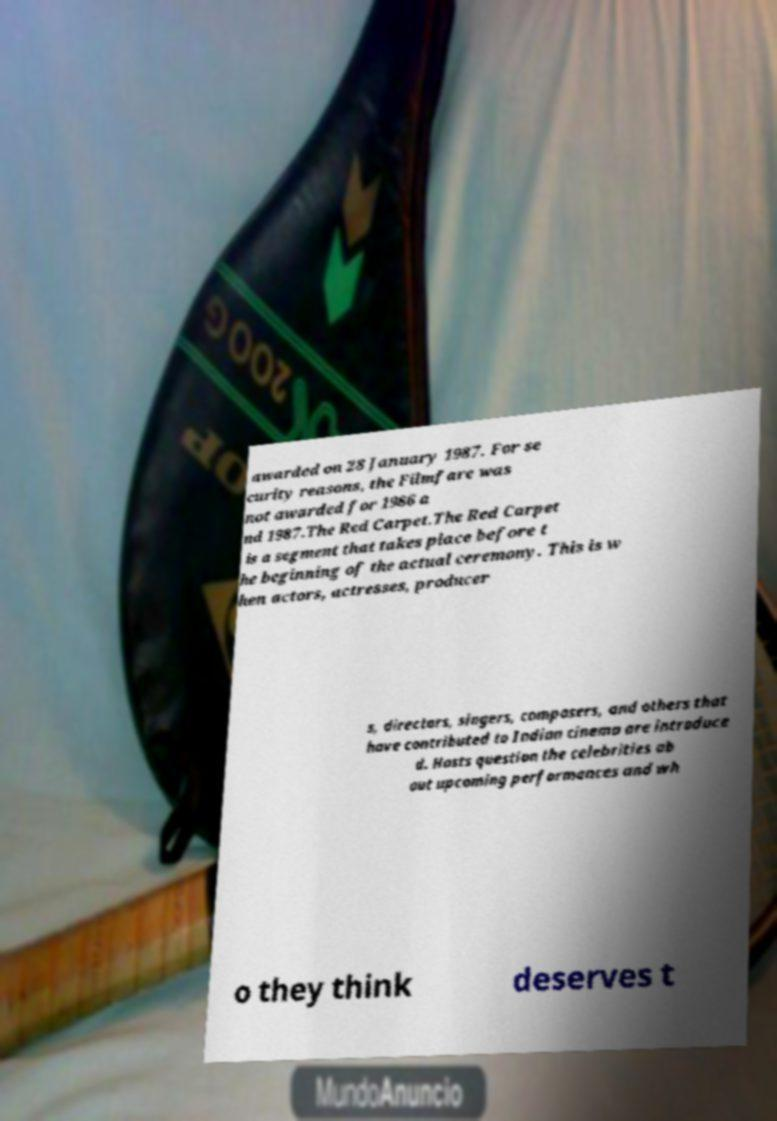Can you accurately transcribe the text from the provided image for me? awarded on 28 January 1987. For se curity reasons, the Filmfare was not awarded for 1986 a nd 1987.The Red Carpet.The Red Carpet is a segment that takes place before t he beginning of the actual ceremony. This is w hen actors, actresses, producer s, directors, singers, composers, and others that have contributed to Indian cinema are introduce d. Hosts question the celebrities ab out upcoming performances and wh o they think deserves t 